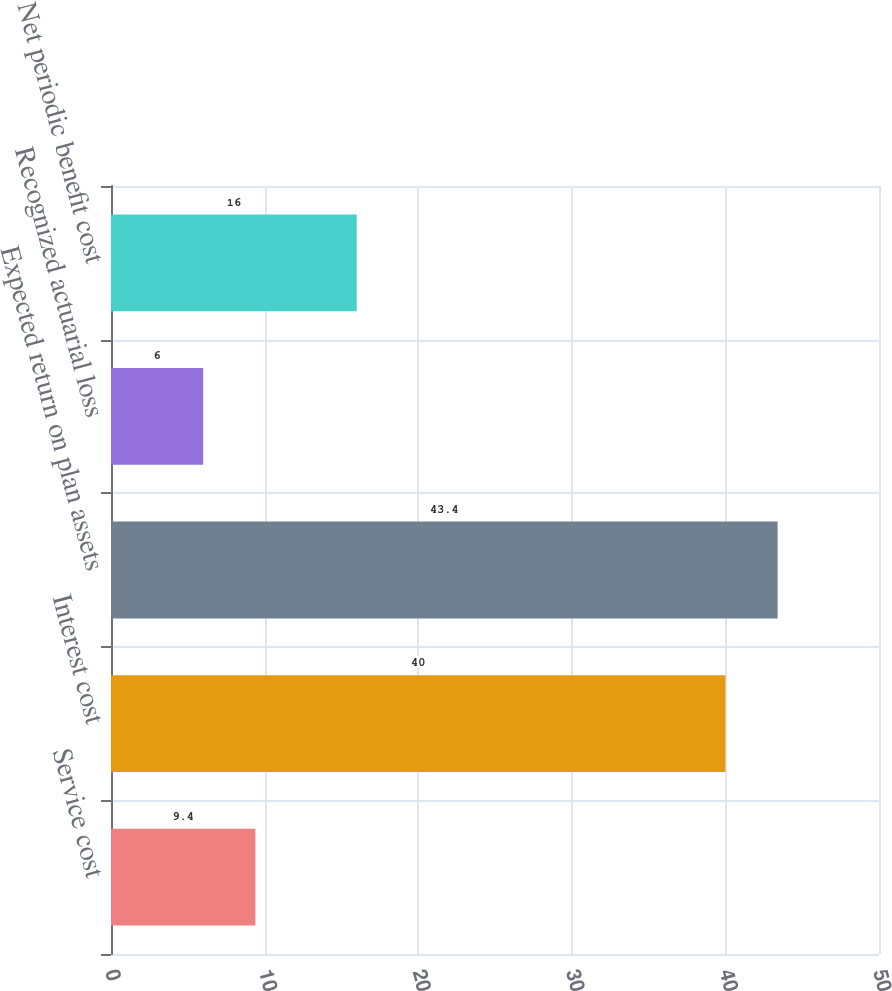Convert chart. <chart><loc_0><loc_0><loc_500><loc_500><bar_chart><fcel>Service cost<fcel>Interest cost<fcel>Expected return on plan assets<fcel>Recognized actuarial loss<fcel>Net periodic benefit cost<nl><fcel>9.4<fcel>40<fcel>43.4<fcel>6<fcel>16<nl></chart> 